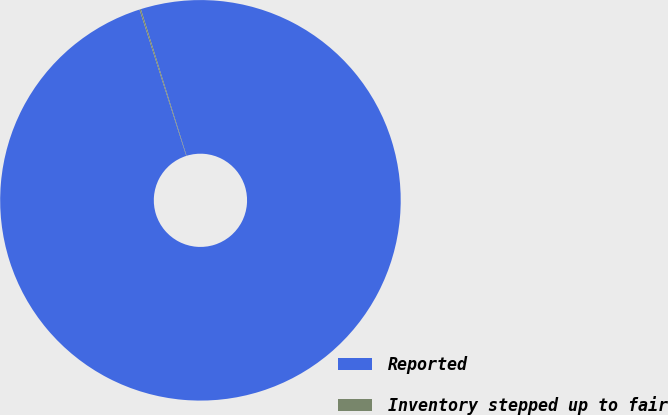Convert chart to OTSL. <chart><loc_0><loc_0><loc_500><loc_500><pie_chart><fcel>Reported<fcel>Inventory stepped up to fair<nl><fcel>99.89%<fcel>0.11%<nl></chart> 